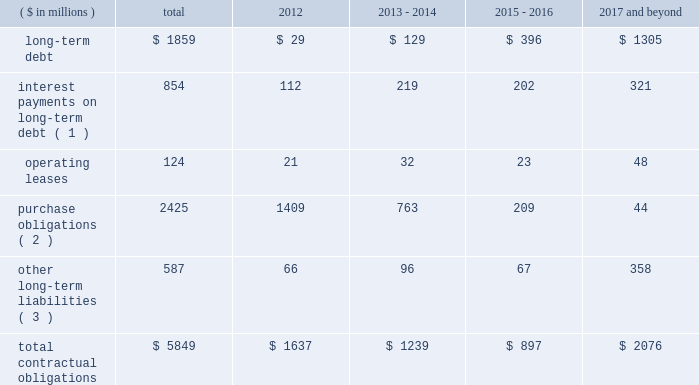Contractual obligations in 2011 , we issued $ 1200 million of senior notes and entered into the credit facility with third-party lenders in the amount of $ 1225 million .
As of december 31 , 2011 , total outstanding long-term debt was $ 1859 million , consisting of these senior notes and the credit facility , in addition to $ 105 million of third party debt that remained outstanding subsequent to the spin-off .
In connection with the spin-off , we entered into a transition services agreement with northrop grumman , under which northrop grumman or certain of its subsidiaries provides us with certain services to help ensure an orderly transition following the distribution .
Under the transition services agreement , northrop grumman provides , for up to 12 months following the spin-off , certain enterprise shared services ( including information technology , resource planning , financial , procurement and human resource services ) , benefits support services and other specified services .
The original term of the transition services agreement ends on march 31 , 2012 , although we have the right to and have cancelled certain services as we transition to new third-party providers .
The services provided by northrop grumman are charged to us at cost , and a limited number of these services may be extended for a period of approximately six months to allow full information systems transition .
See note 20 : related party transactions and former parent company equity in item 8 .
In connection with the spin-off , we entered into a tax matters agreement with northrop grumman ( the 201ctax matters agreement 201d ) that governs the respective rights , responsibilities and obligations of northrop grumman and us after the spin-off with respect to tax liabilities and benefits , tax attributes , tax contests and other tax sharing regarding u.s .
Federal , state , local and foreign income taxes , other taxes and related tax returns .
We have several liabilities with northrop grumman to the irs for the consolidated u.s .
Federal income taxes of the northrop grumman consolidated group relating to the taxable periods in which we were part of that group .
However , the tax matters agreement specifies the portion of this tax liability for which we will bear responsibility , and northrop grumman has agreed to indemnify us against any amounts for which we are not responsible .
The tax matters agreement also provides special rules for allocating tax liabilities in the event that the spin-off , together with certain related transactions , is not tax-free .
See note 20 : related party transactions and former parent company equity in item 8 .
We do not expect either the transition services agreement or the tax matters agreement to have a significant impact on our financial condition and results of operations .
The table presents our contractual obligations as of december 31 , 2011 , and the related estimated timing of future cash payments : ( $ in millions ) total 2012 2013 - 2014 2015 - 2016 2017 and beyond .
( 1 ) interest payments include interest on $ 554 million of variable interest rate debt calculated based on interest rates at december 31 , 2011 .
( 2 ) a 201cpurchase obligation 201d is defined as an agreement to purchase goods or services that is enforceable and legally binding on us and that specifies all significant terms , including : fixed or minimum quantities to be purchased ; fixed , minimum , or variable price provisions ; and the approximate timing of the transaction .
These amounts are primarily comprised of open purchase order commitments to vendors and subcontractors pertaining to funded contracts .
( 3 ) other long-term liabilities primarily consist of total accrued workers 2019 compensation reserves , deferred compensation , and other miscellaneous liabilities , of which $ 201 million is the current portion of workers 2019 compensation liabilities .
It excludes obligations for uncertain tax positions of $ 9 million , as the timing of the payments , if any , cannot be reasonably estimated .
The above table excludes retirement related contributions .
In 2012 , we expect to make minimum and discretionary contributions to our qualified pension plans of approximately $ 153 million and $ 65 million , respectively , exclusive of any u.s .
Government recoveries .
We will continue to periodically evaluate whether to make additional discretionary contributions .
In 2012 , we expect to make $ 35 million in contributions for our other postretirement plans , exclusive of any .
What is the ratio of long term debt to the total contractual obligations? 
Rationale: every $ 1 of total contractual obligations includes $ 0.32 of long term debt
Computations: (1859 / 5849)
Answer: 0.31783. 